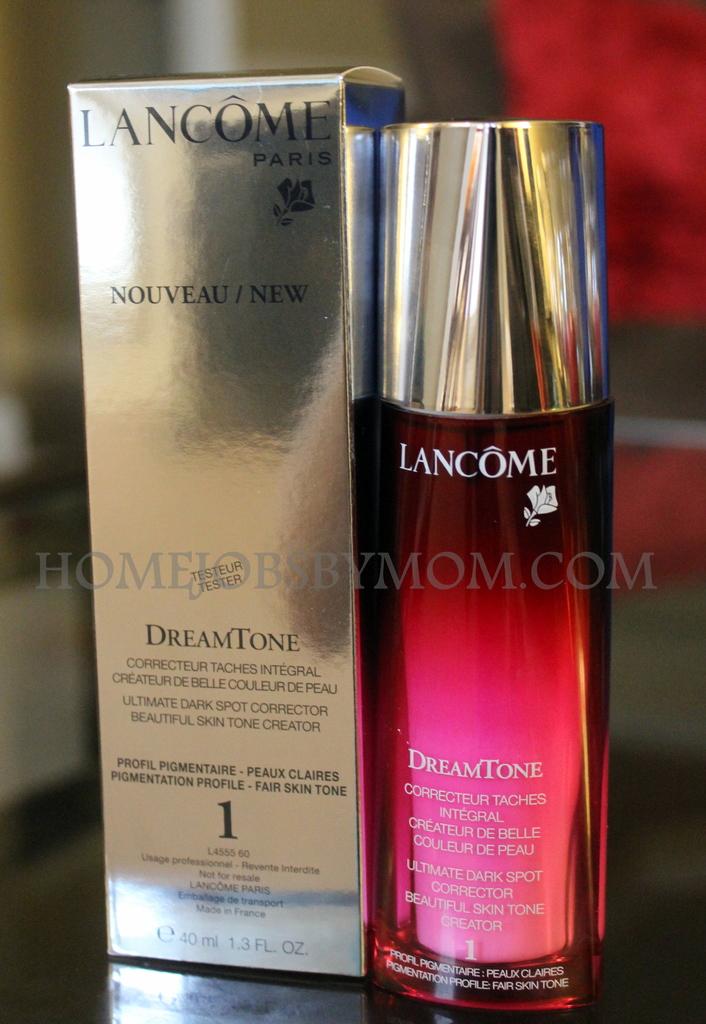Is it a perfume or lotion ?
Your response must be concise. Lotion. Whats the name on the bottle?
Offer a terse response. Lancome. 